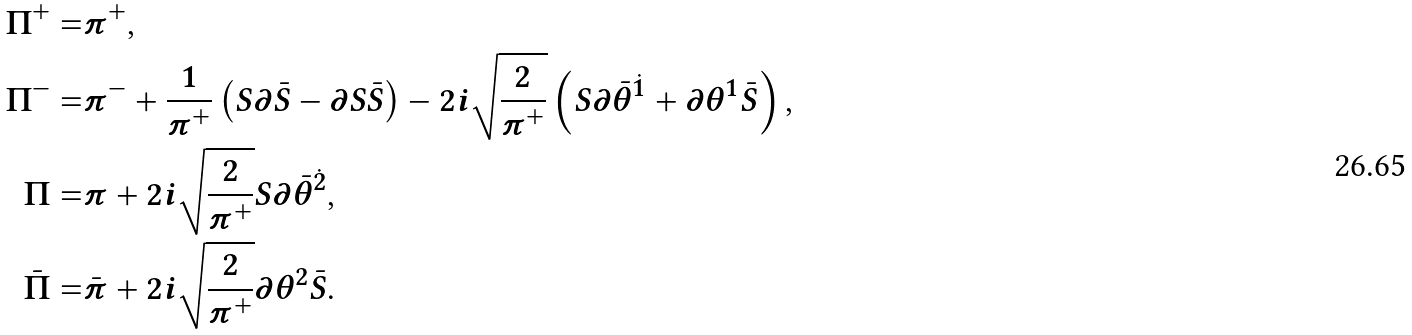Convert formula to latex. <formula><loc_0><loc_0><loc_500><loc_500>\Pi ^ { + } = & \pi ^ { + } , \\ \Pi ^ { - } = & \pi ^ { - } + \frac { 1 } { \pi ^ { + } } \left ( S \partial \bar { S } - \partial S \bar { S } \right ) - 2 i \sqrt { \frac { 2 } { \pi ^ { + } } } \left ( S \partial \bar { \theta } ^ { \dot { 1 } } + \partial \theta ^ { 1 } \bar { S } \right ) , \\ \Pi = & \pi + 2 i \sqrt { \frac { 2 } { \pi ^ { + } } } S \partial \bar { \theta } ^ { \dot { 2 } } , \\ \bar { \Pi } = & \bar { \pi } + 2 i \sqrt { \frac { 2 } { \pi ^ { + } } } \partial \theta ^ { 2 } \bar { S } .</formula> 